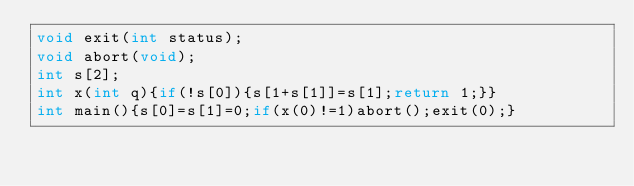Convert code to text. <code><loc_0><loc_0><loc_500><loc_500><_C_>void exit(int status);
void abort(void);
int s[2];
int x(int q){if(!s[0]){s[1+s[1]]=s[1];return 1;}}
int main(){s[0]=s[1]=0;if(x(0)!=1)abort();exit(0);}
</code> 